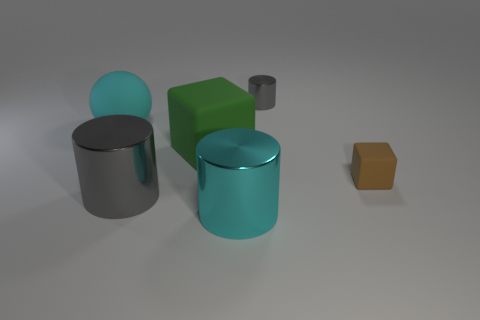What number of other things are the same size as the brown cube?
Keep it short and to the point. 1. Are there an equal number of big cyan rubber objects that are in front of the green matte object and green cubes that are in front of the large gray cylinder?
Offer a very short reply. Yes. What is the big green object made of?
Give a very brief answer. Rubber. What is the thing behind the large rubber sphere made of?
Make the answer very short. Metal. Are there more cyan things that are to the right of the matte sphere than large brown rubber blocks?
Keep it short and to the point. Yes. There is a big shiny cylinder in front of the gray cylinder on the left side of the big rubber block; is there a small object in front of it?
Provide a short and direct response. No. Are there any tiny gray metallic objects right of the big green rubber cube?
Offer a terse response. Yes. How many large shiny cylinders have the same color as the tiny cylinder?
Provide a short and direct response. 1. There is a brown thing that is made of the same material as the cyan sphere; what is its size?
Make the answer very short. Small. There is a gray shiny cylinder left of the gray metallic cylinder that is to the right of the gray metal cylinder in front of the small gray shiny thing; how big is it?
Offer a terse response. Large. 